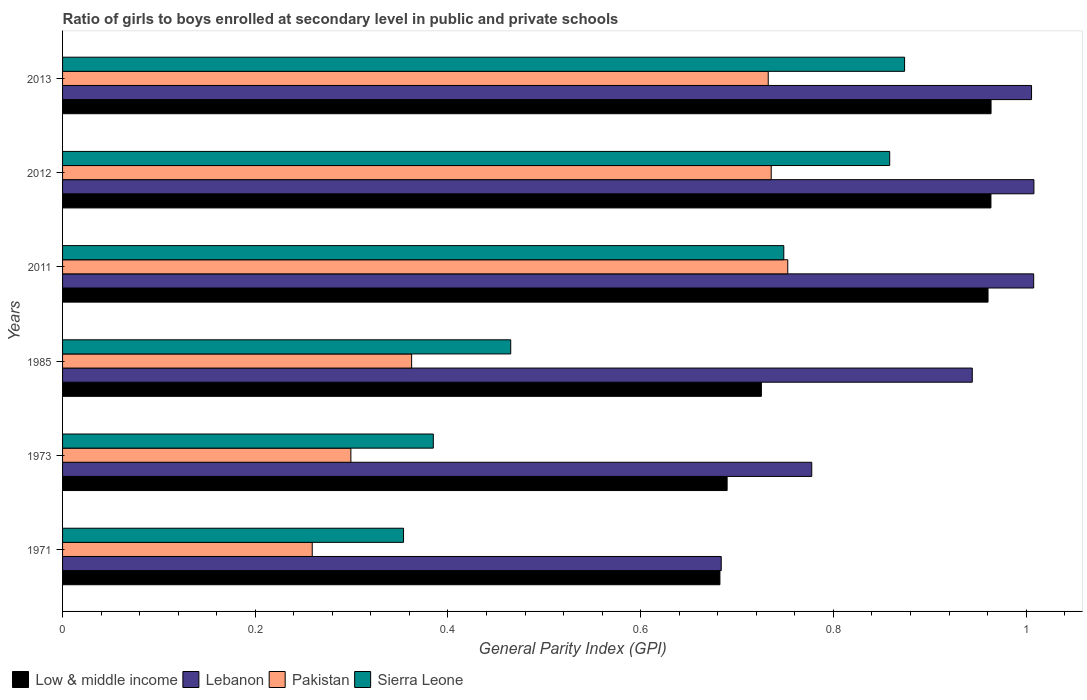How many different coloured bars are there?
Your answer should be very brief. 4. Are the number of bars on each tick of the Y-axis equal?
Offer a terse response. Yes. How many bars are there on the 6th tick from the top?
Your answer should be compact. 4. In how many cases, is the number of bars for a given year not equal to the number of legend labels?
Your answer should be compact. 0. What is the general parity index in Low & middle income in 1985?
Keep it short and to the point. 0.73. Across all years, what is the maximum general parity index in Sierra Leone?
Your response must be concise. 0.87. Across all years, what is the minimum general parity index in Pakistan?
Your response must be concise. 0.26. In which year was the general parity index in Lebanon minimum?
Make the answer very short. 1971. What is the total general parity index in Sierra Leone in the graph?
Offer a very short reply. 3.68. What is the difference between the general parity index in Low & middle income in 1971 and that in 2012?
Provide a succinct answer. -0.28. What is the difference between the general parity index in Pakistan in 2011 and the general parity index in Sierra Leone in 2013?
Your answer should be very brief. -0.12. What is the average general parity index in Sierra Leone per year?
Your response must be concise. 0.61. In the year 2011, what is the difference between the general parity index in Low & middle income and general parity index in Sierra Leone?
Give a very brief answer. 0.21. In how many years, is the general parity index in Low & middle income greater than 0.7200000000000001 ?
Your response must be concise. 4. What is the ratio of the general parity index in Low & middle income in 2011 to that in 2012?
Your response must be concise. 1. Is the general parity index in Pakistan in 1971 less than that in 2012?
Make the answer very short. Yes. What is the difference between the highest and the second highest general parity index in Lebanon?
Ensure brevity in your answer.  0. What is the difference between the highest and the lowest general parity index in Low & middle income?
Your answer should be very brief. 0.28. In how many years, is the general parity index in Low & middle income greater than the average general parity index in Low & middle income taken over all years?
Offer a terse response. 3. Is the sum of the general parity index in Pakistan in 1973 and 2012 greater than the maximum general parity index in Low & middle income across all years?
Keep it short and to the point. Yes. What does the 4th bar from the top in 1971 represents?
Give a very brief answer. Low & middle income. Is it the case that in every year, the sum of the general parity index in Pakistan and general parity index in Sierra Leone is greater than the general parity index in Lebanon?
Make the answer very short. No. How many bars are there?
Ensure brevity in your answer.  24. How many years are there in the graph?
Make the answer very short. 6. What is the difference between two consecutive major ticks on the X-axis?
Offer a very short reply. 0.2. Are the values on the major ticks of X-axis written in scientific E-notation?
Your response must be concise. No. What is the title of the graph?
Your answer should be compact. Ratio of girls to boys enrolled at secondary level in public and private schools. What is the label or title of the X-axis?
Give a very brief answer. General Parity Index (GPI). What is the General Parity Index (GPI) in Low & middle income in 1971?
Give a very brief answer. 0.68. What is the General Parity Index (GPI) of Lebanon in 1971?
Give a very brief answer. 0.68. What is the General Parity Index (GPI) of Pakistan in 1971?
Your answer should be compact. 0.26. What is the General Parity Index (GPI) in Sierra Leone in 1971?
Ensure brevity in your answer.  0.35. What is the General Parity Index (GPI) in Low & middle income in 1973?
Provide a short and direct response. 0.69. What is the General Parity Index (GPI) of Lebanon in 1973?
Make the answer very short. 0.78. What is the General Parity Index (GPI) of Pakistan in 1973?
Ensure brevity in your answer.  0.3. What is the General Parity Index (GPI) in Sierra Leone in 1973?
Provide a succinct answer. 0.38. What is the General Parity Index (GPI) of Low & middle income in 1985?
Offer a very short reply. 0.73. What is the General Parity Index (GPI) of Lebanon in 1985?
Provide a short and direct response. 0.94. What is the General Parity Index (GPI) of Pakistan in 1985?
Ensure brevity in your answer.  0.36. What is the General Parity Index (GPI) of Sierra Leone in 1985?
Offer a terse response. 0.47. What is the General Parity Index (GPI) in Low & middle income in 2011?
Keep it short and to the point. 0.96. What is the General Parity Index (GPI) of Lebanon in 2011?
Your response must be concise. 1.01. What is the General Parity Index (GPI) in Pakistan in 2011?
Provide a succinct answer. 0.75. What is the General Parity Index (GPI) of Sierra Leone in 2011?
Make the answer very short. 0.75. What is the General Parity Index (GPI) of Low & middle income in 2012?
Provide a short and direct response. 0.96. What is the General Parity Index (GPI) in Lebanon in 2012?
Give a very brief answer. 1.01. What is the General Parity Index (GPI) in Pakistan in 2012?
Your answer should be compact. 0.74. What is the General Parity Index (GPI) of Sierra Leone in 2012?
Your answer should be very brief. 0.86. What is the General Parity Index (GPI) of Low & middle income in 2013?
Offer a very short reply. 0.96. What is the General Parity Index (GPI) in Lebanon in 2013?
Offer a terse response. 1.01. What is the General Parity Index (GPI) of Pakistan in 2013?
Provide a short and direct response. 0.73. What is the General Parity Index (GPI) of Sierra Leone in 2013?
Your answer should be compact. 0.87. Across all years, what is the maximum General Parity Index (GPI) in Low & middle income?
Keep it short and to the point. 0.96. Across all years, what is the maximum General Parity Index (GPI) of Lebanon?
Keep it short and to the point. 1.01. Across all years, what is the maximum General Parity Index (GPI) in Pakistan?
Your response must be concise. 0.75. Across all years, what is the maximum General Parity Index (GPI) of Sierra Leone?
Ensure brevity in your answer.  0.87. Across all years, what is the minimum General Parity Index (GPI) in Low & middle income?
Ensure brevity in your answer.  0.68. Across all years, what is the minimum General Parity Index (GPI) in Lebanon?
Your answer should be compact. 0.68. Across all years, what is the minimum General Parity Index (GPI) of Pakistan?
Provide a short and direct response. 0.26. Across all years, what is the minimum General Parity Index (GPI) in Sierra Leone?
Provide a short and direct response. 0.35. What is the total General Parity Index (GPI) of Low & middle income in the graph?
Give a very brief answer. 4.98. What is the total General Parity Index (GPI) of Lebanon in the graph?
Provide a short and direct response. 5.43. What is the total General Parity Index (GPI) in Pakistan in the graph?
Your answer should be compact. 3.14. What is the total General Parity Index (GPI) in Sierra Leone in the graph?
Provide a succinct answer. 3.68. What is the difference between the General Parity Index (GPI) of Low & middle income in 1971 and that in 1973?
Offer a very short reply. -0.01. What is the difference between the General Parity Index (GPI) in Lebanon in 1971 and that in 1973?
Offer a very short reply. -0.09. What is the difference between the General Parity Index (GPI) of Pakistan in 1971 and that in 1973?
Give a very brief answer. -0.04. What is the difference between the General Parity Index (GPI) of Sierra Leone in 1971 and that in 1973?
Keep it short and to the point. -0.03. What is the difference between the General Parity Index (GPI) of Low & middle income in 1971 and that in 1985?
Keep it short and to the point. -0.04. What is the difference between the General Parity Index (GPI) of Lebanon in 1971 and that in 1985?
Give a very brief answer. -0.26. What is the difference between the General Parity Index (GPI) in Pakistan in 1971 and that in 1985?
Give a very brief answer. -0.1. What is the difference between the General Parity Index (GPI) of Sierra Leone in 1971 and that in 1985?
Ensure brevity in your answer.  -0.11. What is the difference between the General Parity Index (GPI) of Low & middle income in 1971 and that in 2011?
Your answer should be compact. -0.28. What is the difference between the General Parity Index (GPI) of Lebanon in 1971 and that in 2011?
Offer a terse response. -0.32. What is the difference between the General Parity Index (GPI) of Pakistan in 1971 and that in 2011?
Give a very brief answer. -0.49. What is the difference between the General Parity Index (GPI) of Sierra Leone in 1971 and that in 2011?
Your answer should be very brief. -0.39. What is the difference between the General Parity Index (GPI) of Low & middle income in 1971 and that in 2012?
Your response must be concise. -0.28. What is the difference between the General Parity Index (GPI) in Lebanon in 1971 and that in 2012?
Provide a short and direct response. -0.32. What is the difference between the General Parity Index (GPI) in Pakistan in 1971 and that in 2012?
Your answer should be compact. -0.48. What is the difference between the General Parity Index (GPI) in Sierra Leone in 1971 and that in 2012?
Ensure brevity in your answer.  -0.5. What is the difference between the General Parity Index (GPI) in Low & middle income in 1971 and that in 2013?
Give a very brief answer. -0.28. What is the difference between the General Parity Index (GPI) of Lebanon in 1971 and that in 2013?
Keep it short and to the point. -0.32. What is the difference between the General Parity Index (GPI) of Pakistan in 1971 and that in 2013?
Offer a very short reply. -0.47. What is the difference between the General Parity Index (GPI) in Sierra Leone in 1971 and that in 2013?
Your response must be concise. -0.52. What is the difference between the General Parity Index (GPI) of Low & middle income in 1973 and that in 1985?
Your answer should be very brief. -0.04. What is the difference between the General Parity Index (GPI) of Lebanon in 1973 and that in 1985?
Your response must be concise. -0.17. What is the difference between the General Parity Index (GPI) in Pakistan in 1973 and that in 1985?
Your answer should be very brief. -0.06. What is the difference between the General Parity Index (GPI) in Sierra Leone in 1973 and that in 1985?
Your answer should be compact. -0.08. What is the difference between the General Parity Index (GPI) in Low & middle income in 1973 and that in 2011?
Provide a short and direct response. -0.27. What is the difference between the General Parity Index (GPI) in Lebanon in 1973 and that in 2011?
Make the answer very short. -0.23. What is the difference between the General Parity Index (GPI) of Pakistan in 1973 and that in 2011?
Your answer should be very brief. -0.45. What is the difference between the General Parity Index (GPI) of Sierra Leone in 1973 and that in 2011?
Provide a short and direct response. -0.36. What is the difference between the General Parity Index (GPI) in Low & middle income in 1973 and that in 2012?
Ensure brevity in your answer.  -0.27. What is the difference between the General Parity Index (GPI) of Lebanon in 1973 and that in 2012?
Keep it short and to the point. -0.23. What is the difference between the General Parity Index (GPI) of Pakistan in 1973 and that in 2012?
Ensure brevity in your answer.  -0.44. What is the difference between the General Parity Index (GPI) of Sierra Leone in 1973 and that in 2012?
Offer a very short reply. -0.47. What is the difference between the General Parity Index (GPI) in Low & middle income in 1973 and that in 2013?
Provide a succinct answer. -0.27. What is the difference between the General Parity Index (GPI) in Lebanon in 1973 and that in 2013?
Offer a terse response. -0.23. What is the difference between the General Parity Index (GPI) in Pakistan in 1973 and that in 2013?
Provide a succinct answer. -0.43. What is the difference between the General Parity Index (GPI) in Sierra Leone in 1973 and that in 2013?
Offer a very short reply. -0.49. What is the difference between the General Parity Index (GPI) in Low & middle income in 1985 and that in 2011?
Offer a terse response. -0.24. What is the difference between the General Parity Index (GPI) in Lebanon in 1985 and that in 2011?
Your answer should be compact. -0.06. What is the difference between the General Parity Index (GPI) of Pakistan in 1985 and that in 2011?
Offer a very short reply. -0.39. What is the difference between the General Parity Index (GPI) in Sierra Leone in 1985 and that in 2011?
Offer a terse response. -0.28. What is the difference between the General Parity Index (GPI) in Low & middle income in 1985 and that in 2012?
Offer a very short reply. -0.24. What is the difference between the General Parity Index (GPI) in Lebanon in 1985 and that in 2012?
Keep it short and to the point. -0.06. What is the difference between the General Parity Index (GPI) of Pakistan in 1985 and that in 2012?
Offer a terse response. -0.37. What is the difference between the General Parity Index (GPI) of Sierra Leone in 1985 and that in 2012?
Offer a very short reply. -0.39. What is the difference between the General Parity Index (GPI) in Low & middle income in 1985 and that in 2013?
Ensure brevity in your answer.  -0.24. What is the difference between the General Parity Index (GPI) in Lebanon in 1985 and that in 2013?
Ensure brevity in your answer.  -0.06. What is the difference between the General Parity Index (GPI) of Pakistan in 1985 and that in 2013?
Provide a succinct answer. -0.37. What is the difference between the General Parity Index (GPI) in Sierra Leone in 1985 and that in 2013?
Offer a very short reply. -0.41. What is the difference between the General Parity Index (GPI) of Low & middle income in 2011 and that in 2012?
Provide a succinct answer. -0. What is the difference between the General Parity Index (GPI) in Lebanon in 2011 and that in 2012?
Provide a succinct answer. -0. What is the difference between the General Parity Index (GPI) of Pakistan in 2011 and that in 2012?
Keep it short and to the point. 0.02. What is the difference between the General Parity Index (GPI) of Sierra Leone in 2011 and that in 2012?
Offer a terse response. -0.11. What is the difference between the General Parity Index (GPI) of Low & middle income in 2011 and that in 2013?
Provide a succinct answer. -0. What is the difference between the General Parity Index (GPI) of Lebanon in 2011 and that in 2013?
Keep it short and to the point. 0. What is the difference between the General Parity Index (GPI) in Pakistan in 2011 and that in 2013?
Offer a very short reply. 0.02. What is the difference between the General Parity Index (GPI) of Sierra Leone in 2011 and that in 2013?
Your answer should be very brief. -0.13. What is the difference between the General Parity Index (GPI) in Low & middle income in 2012 and that in 2013?
Your response must be concise. -0. What is the difference between the General Parity Index (GPI) of Lebanon in 2012 and that in 2013?
Your response must be concise. 0. What is the difference between the General Parity Index (GPI) in Pakistan in 2012 and that in 2013?
Your answer should be very brief. 0. What is the difference between the General Parity Index (GPI) in Sierra Leone in 2012 and that in 2013?
Your answer should be compact. -0.02. What is the difference between the General Parity Index (GPI) of Low & middle income in 1971 and the General Parity Index (GPI) of Lebanon in 1973?
Keep it short and to the point. -0.1. What is the difference between the General Parity Index (GPI) of Low & middle income in 1971 and the General Parity Index (GPI) of Pakistan in 1973?
Provide a short and direct response. 0.38. What is the difference between the General Parity Index (GPI) in Low & middle income in 1971 and the General Parity Index (GPI) in Sierra Leone in 1973?
Provide a succinct answer. 0.3. What is the difference between the General Parity Index (GPI) of Lebanon in 1971 and the General Parity Index (GPI) of Pakistan in 1973?
Offer a very short reply. 0.38. What is the difference between the General Parity Index (GPI) of Lebanon in 1971 and the General Parity Index (GPI) of Sierra Leone in 1973?
Ensure brevity in your answer.  0.3. What is the difference between the General Parity Index (GPI) of Pakistan in 1971 and the General Parity Index (GPI) of Sierra Leone in 1973?
Give a very brief answer. -0.13. What is the difference between the General Parity Index (GPI) of Low & middle income in 1971 and the General Parity Index (GPI) of Lebanon in 1985?
Your answer should be very brief. -0.26. What is the difference between the General Parity Index (GPI) of Low & middle income in 1971 and the General Parity Index (GPI) of Pakistan in 1985?
Offer a very short reply. 0.32. What is the difference between the General Parity Index (GPI) of Low & middle income in 1971 and the General Parity Index (GPI) of Sierra Leone in 1985?
Keep it short and to the point. 0.22. What is the difference between the General Parity Index (GPI) in Lebanon in 1971 and the General Parity Index (GPI) in Pakistan in 1985?
Provide a succinct answer. 0.32. What is the difference between the General Parity Index (GPI) in Lebanon in 1971 and the General Parity Index (GPI) in Sierra Leone in 1985?
Offer a terse response. 0.22. What is the difference between the General Parity Index (GPI) in Pakistan in 1971 and the General Parity Index (GPI) in Sierra Leone in 1985?
Offer a very short reply. -0.21. What is the difference between the General Parity Index (GPI) of Low & middle income in 1971 and the General Parity Index (GPI) of Lebanon in 2011?
Offer a very short reply. -0.33. What is the difference between the General Parity Index (GPI) of Low & middle income in 1971 and the General Parity Index (GPI) of Pakistan in 2011?
Offer a very short reply. -0.07. What is the difference between the General Parity Index (GPI) in Low & middle income in 1971 and the General Parity Index (GPI) in Sierra Leone in 2011?
Provide a succinct answer. -0.07. What is the difference between the General Parity Index (GPI) in Lebanon in 1971 and the General Parity Index (GPI) in Pakistan in 2011?
Your answer should be compact. -0.07. What is the difference between the General Parity Index (GPI) of Lebanon in 1971 and the General Parity Index (GPI) of Sierra Leone in 2011?
Your answer should be compact. -0.06. What is the difference between the General Parity Index (GPI) in Pakistan in 1971 and the General Parity Index (GPI) in Sierra Leone in 2011?
Make the answer very short. -0.49. What is the difference between the General Parity Index (GPI) of Low & middle income in 1971 and the General Parity Index (GPI) of Lebanon in 2012?
Give a very brief answer. -0.33. What is the difference between the General Parity Index (GPI) of Low & middle income in 1971 and the General Parity Index (GPI) of Pakistan in 2012?
Your response must be concise. -0.05. What is the difference between the General Parity Index (GPI) in Low & middle income in 1971 and the General Parity Index (GPI) in Sierra Leone in 2012?
Offer a terse response. -0.18. What is the difference between the General Parity Index (GPI) in Lebanon in 1971 and the General Parity Index (GPI) in Pakistan in 2012?
Provide a short and direct response. -0.05. What is the difference between the General Parity Index (GPI) of Lebanon in 1971 and the General Parity Index (GPI) of Sierra Leone in 2012?
Provide a succinct answer. -0.17. What is the difference between the General Parity Index (GPI) of Pakistan in 1971 and the General Parity Index (GPI) of Sierra Leone in 2012?
Keep it short and to the point. -0.6. What is the difference between the General Parity Index (GPI) in Low & middle income in 1971 and the General Parity Index (GPI) in Lebanon in 2013?
Offer a very short reply. -0.32. What is the difference between the General Parity Index (GPI) in Low & middle income in 1971 and the General Parity Index (GPI) in Pakistan in 2013?
Ensure brevity in your answer.  -0.05. What is the difference between the General Parity Index (GPI) in Low & middle income in 1971 and the General Parity Index (GPI) in Sierra Leone in 2013?
Provide a short and direct response. -0.19. What is the difference between the General Parity Index (GPI) of Lebanon in 1971 and the General Parity Index (GPI) of Pakistan in 2013?
Provide a succinct answer. -0.05. What is the difference between the General Parity Index (GPI) in Lebanon in 1971 and the General Parity Index (GPI) in Sierra Leone in 2013?
Your response must be concise. -0.19. What is the difference between the General Parity Index (GPI) of Pakistan in 1971 and the General Parity Index (GPI) of Sierra Leone in 2013?
Your answer should be compact. -0.61. What is the difference between the General Parity Index (GPI) of Low & middle income in 1973 and the General Parity Index (GPI) of Lebanon in 1985?
Ensure brevity in your answer.  -0.25. What is the difference between the General Parity Index (GPI) in Low & middle income in 1973 and the General Parity Index (GPI) in Pakistan in 1985?
Provide a succinct answer. 0.33. What is the difference between the General Parity Index (GPI) in Low & middle income in 1973 and the General Parity Index (GPI) in Sierra Leone in 1985?
Keep it short and to the point. 0.22. What is the difference between the General Parity Index (GPI) of Lebanon in 1973 and the General Parity Index (GPI) of Pakistan in 1985?
Ensure brevity in your answer.  0.42. What is the difference between the General Parity Index (GPI) of Lebanon in 1973 and the General Parity Index (GPI) of Sierra Leone in 1985?
Your answer should be compact. 0.31. What is the difference between the General Parity Index (GPI) of Pakistan in 1973 and the General Parity Index (GPI) of Sierra Leone in 1985?
Your answer should be very brief. -0.17. What is the difference between the General Parity Index (GPI) of Low & middle income in 1973 and the General Parity Index (GPI) of Lebanon in 2011?
Offer a very short reply. -0.32. What is the difference between the General Parity Index (GPI) of Low & middle income in 1973 and the General Parity Index (GPI) of Pakistan in 2011?
Make the answer very short. -0.06. What is the difference between the General Parity Index (GPI) in Low & middle income in 1973 and the General Parity Index (GPI) in Sierra Leone in 2011?
Your response must be concise. -0.06. What is the difference between the General Parity Index (GPI) of Lebanon in 1973 and the General Parity Index (GPI) of Pakistan in 2011?
Keep it short and to the point. 0.02. What is the difference between the General Parity Index (GPI) of Lebanon in 1973 and the General Parity Index (GPI) of Sierra Leone in 2011?
Give a very brief answer. 0.03. What is the difference between the General Parity Index (GPI) in Pakistan in 1973 and the General Parity Index (GPI) in Sierra Leone in 2011?
Keep it short and to the point. -0.45. What is the difference between the General Parity Index (GPI) of Low & middle income in 1973 and the General Parity Index (GPI) of Lebanon in 2012?
Your response must be concise. -0.32. What is the difference between the General Parity Index (GPI) in Low & middle income in 1973 and the General Parity Index (GPI) in Pakistan in 2012?
Offer a very short reply. -0.05. What is the difference between the General Parity Index (GPI) of Low & middle income in 1973 and the General Parity Index (GPI) of Sierra Leone in 2012?
Ensure brevity in your answer.  -0.17. What is the difference between the General Parity Index (GPI) of Lebanon in 1973 and the General Parity Index (GPI) of Pakistan in 2012?
Provide a succinct answer. 0.04. What is the difference between the General Parity Index (GPI) in Lebanon in 1973 and the General Parity Index (GPI) in Sierra Leone in 2012?
Keep it short and to the point. -0.08. What is the difference between the General Parity Index (GPI) of Pakistan in 1973 and the General Parity Index (GPI) of Sierra Leone in 2012?
Your answer should be very brief. -0.56. What is the difference between the General Parity Index (GPI) in Low & middle income in 1973 and the General Parity Index (GPI) in Lebanon in 2013?
Make the answer very short. -0.32. What is the difference between the General Parity Index (GPI) of Low & middle income in 1973 and the General Parity Index (GPI) of Pakistan in 2013?
Make the answer very short. -0.04. What is the difference between the General Parity Index (GPI) of Low & middle income in 1973 and the General Parity Index (GPI) of Sierra Leone in 2013?
Offer a very short reply. -0.18. What is the difference between the General Parity Index (GPI) in Lebanon in 1973 and the General Parity Index (GPI) in Pakistan in 2013?
Give a very brief answer. 0.05. What is the difference between the General Parity Index (GPI) of Lebanon in 1973 and the General Parity Index (GPI) of Sierra Leone in 2013?
Offer a very short reply. -0.1. What is the difference between the General Parity Index (GPI) of Pakistan in 1973 and the General Parity Index (GPI) of Sierra Leone in 2013?
Keep it short and to the point. -0.57. What is the difference between the General Parity Index (GPI) in Low & middle income in 1985 and the General Parity Index (GPI) in Lebanon in 2011?
Give a very brief answer. -0.28. What is the difference between the General Parity Index (GPI) in Low & middle income in 1985 and the General Parity Index (GPI) in Pakistan in 2011?
Keep it short and to the point. -0.03. What is the difference between the General Parity Index (GPI) of Low & middle income in 1985 and the General Parity Index (GPI) of Sierra Leone in 2011?
Keep it short and to the point. -0.02. What is the difference between the General Parity Index (GPI) of Lebanon in 1985 and the General Parity Index (GPI) of Pakistan in 2011?
Keep it short and to the point. 0.19. What is the difference between the General Parity Index (GPI) of Lebanon in 1985 and the General Parity Index (GPI) of Sierra Leone in 2011?
Your response must be concise. 0.2. What is the difference between the General Parity Index (GPI) in Pakistan in 1985 and the General Parity Index (GPI) in Sierra Leone in 2011?
Your answer should be compact. -0.39. What is the difference between the General Parity Index (GPI) of Low & middle income in 1985 and the General Parity Index (GPI) of Lebanon in 2012?
Offer a very short reply. -0.28. What is the difference between the General Parity Index (GPI) in Low & middle income in 1985 and the General Parity Index (GPI) in Pakistan in 2012?
Keep it short and to the point. -0.01. What is the difference between the General Parity Index (GPI) in Low & middle income in 1985 and the General Parity Index (GPI) in Sierra Leone in 2012?
Offer a terse response. -0.13. What is the difference between the General Parity Index (GPI) of Lebanon in 1985 and the General Parity Index (GPI) of Pakistan in 2012?
Offer a terse response. 0.21. What is the difference between the General Parity Index (GPI) of Lebanon in 1985 and the General Parity Index (GPI) of Sierra Leone in 2012?
Make the answer very short. 0.09. What is the difference between the General Parity Index (GPI) of Pakistan in 1985 and the General Parity Index (GPI) of Sierra Leone in 2012?
Your answer should be compact. -0.5. What is the difference between the General Parity Index (GPI) of Low & middle income in 1985 and the General Parity Index (GPI) of Lebanon in 2013?
Your answer should be very brief. -0.28. What is the difference between the General Parity Index (GPI) in Low & middle income in 1985 and the General Parity Index (GPI) in Pakistan in 2013?
Make the answer very short. -0.01. What is the difference between the General Parity Index (GPI) of Low & middle income in 1985 and the General Parity Index (GPI) of Sierra Leone in 2013?
Your answer should be very brief. -0.15. What is the difference between the General Parity Index (GPI) of Lebanon in 1985 and the General Parity Index (GPI) of Pakistan in 2013?
Your answer should be compact. 0.21. What is the difference between the General Parity Index (GPI) in Lebanon in 1985 and the General Parity Index (GPI) in Sierra Leone in 2013?
Your answer should be compact. 0.07. What is the difference between the General Parity Index (GPI) in Pakistan in 1985 and the General Parity Index (GPI) in Sierra Leone in 2013?
Offer a very short reply. -0.51. What is the difference between the General Parity Index (GPI) in Low & middle income in 2011 and the General Parity Index (GPI) in Lebanon in 2012?
Give a very brief answer. -0.05. What is the difference between the General Parity Index (GPI) of Low & middle income in 2011 and the General Parity Index (GPI) of Pakistan in 2012?
Your answer should be very brief. 0.23. What is the difference between the General Parity Index (GPI) in Low & middle income in 2011 and the General Parity Index (GPI) in Sierra Leone in 2012?
Offer a very short reply. 0.1. What is the difference between the General Parity Index (GPI) in Lebanon in 2011 and the General Parity Index (GPI) in Pakistan in 2012?
Give a very brief answer. 0.27. What is the difference between the General Parity Index (GPI) of Lebanon in 2011 and the General Parity Index (GPI) of Sierra Leone in 2012?
Offer a very short reply. 0.15. What is the difference between the General Parity Index (GPI) in Pakistan in 2011 and the General Parity Index (GPI) in Sierra Leone in 2012?
Your answer should be compact. -0.11. What is the difference between the General Parity Index (GPI) in Low & middle income in 2011 and the General Parity Index (GPI) in Lebanon in 2013?
Provide a succinct answer. -0.05. What is the difference between the General Parity Index (GPI) of Low & middle income in 2011 and the General Parity Index (GPI) of Pakistan in 2013?
Your response must be concise. 0.23. What is the difference between the General Parity Index (GPI) in Low & middle income in 2011 and the General Parity Index (GPI) in Sierra Leone in 2013?
Offer a terse response. 0.09. What is the difference between the General Parity Index (GPI) in Lebanon in 2011 and the General Parity Index (GPI) in Pakistan in 2013?
Your answer should be very brief. 0.28. What is the difference between the General Parity Index (GPI) in Lebanon in 2011 and the General Parity Index (GPI) in Sierra Leone in 2013?
Your response must be concise. 0.13. What is the difference between the General Parity Index (GPI) of Pakistan in 2011 and the General Parity Index (GPI) of Sierra Leone in 2013?
Provide a short and direct response. -0.12. What is the difference between the General Parity Index (GPI) of Low & middle income in 2012 and the General Parity Index (GPI) of Lebanon in 2013?
Offer a very short reply. -0.04. What is the difference between the General Parity Index (GPI) in Low & middle income in 2012 and the General Parity Index (GPI) in Pakistan in 2013?
Provide a succinct answer. 0.23. What is the difference between the General Parity Index (GPI) of Low & middle income in 2012 and the General Parity Index (GPI) of Sierra Leone in 2013?
Your answer should be very brief. 0.09. What is the difference between the General Parity Index (GPI) in Lebanon in 2012 and the General Parity Index (GPI) in Pakistan in 2013?
Your response must be concise. 0.28. What is the difference between the General Parity Index (GPI) in Lebanon in 2012 and the General Parity Index (GPI) in Sierra Leone in 2013?
Provide a short and direct response. 0.13. What is the difference between the General Parity Index (GPI) of Pakistan in 2012 and the General Parity Index (GPI) of Sierra Leone in 2013?
Your answer should be very brief. -0.14. What is the average General Parity Index (GPI) in Low & middle income per year?
Provide a succinct answer. 0.83. What is the average General Parity Index (GPI) in Lebanon per year?
Offer a terse response. 0.9. What is the average General Parity Index (GPI) of Pakistan per year?
Your answer should be very brief. 0.52. What is the average General Parity Index (GPI) of Sierra Leone per year?
Your answer should be compact. 0.61. In the year 1971, what is the difference between the General Parity Index (GPI) of Low & middle income and General Parity Index (GPI) of Lebanon?
Make the answer very short. -0. In the year 1971, what is the difference between the General Parity Index (GPI) in Low & middle income and General Parity Index (GPI) in Pakistan?
Provide a short and direct response. 0.42. In the year 1971, what is the difference between the General Parity Index (GPI) in Low & middle income and General Parity Index (GPI) in Sierra Leone?
Make the answer very short. 0.33. In the year 1971, what is the difference between the General Parity Index (GPI) in Lebanon and General Parity Index (GPI) in Pakistan?
Your answer should be very brief. 0.42. In the year 1971, what is the difference between the General Parity Index (GPI) of Lebanon and General Parity Index (GPI) of Sierra Leone?
Your response must be concise. 0.33. In the year 1971, what is the difference between the General Parity Index (GPI) of Pakistan and General Parity Index (GPI) of Sierra Leone?
Offer a terse response. -0.09. In the year 1973, what is the difference between the General Parity Index (GPI) in Low & middle income and General Parity Index (GPI) in Lebanon?
Provide a succinct answer. -0.09. In the year 1973, what is the difference between the General Parity Index (GPI) of Low & middle income and General Parity Index (GPI) of Pakistan?
Offer a terse response. 0.39. In the year 1973, what is the difference between the General Parity Index (GPI) in Low & middle income and General Parity Index (GPI) in Sierra Leone?
Give a very brief answer. 0.3. In the year 1973, what is the difference between the General Parity Index (GPI) in Lebanon and General Parity Index (GPI) in Pakistan?
Give a very brief answer. 0.48. In the year 1973, what is the difference between the General Parity Index (GPI) of Lebanon and General Parity Index (GPI) of Sierra Leone?
Ensure brevity in your answer.  0.39. In the year 1973, what is the difference between the General Parity Index (GPI) of Pakistan and General Parity Index (GPI) of Sierra Leone?
Provide a short and direct response. -0.09. In the year 1985, what is the difference between the General Parity Index (GPI) of Low & middle income and General Parity Index (GPI) of Lebanon?
Your response must be concise. -0.22. In the year 1985, what is the difference between the General Parity Index (GPI) in Low & middle income and General Parity Index (GPI) in Pakistan?
Give a very brief answer. 0.36. In the year 1985, what is the difference between the General Parity Index (GPI) in Low & middle income and General Parity Index (GPI) in Sierra Leone?
Your answer should be very brief. 0.26. In the year 1985, what is the difference between the General Parity Index (GPI) in Lebanon and General Parity Index (GPI) in Pakistan?
Give a very brief answer. 0.58. In the year 1985, what is the difference between the General Parity Index (GPI) of Lebanon and General Parity Index (GPI) of Sierra Leone?
Your answer should be very brief. 0.48. In the year 1985, what is the difference between the General Parity Index (GPI) in Pakistan and General Parity Index (GPI) in Sierra Leone?
Give a very brief answer. -0.1. In the year 2011, what is the difference between the General Parity Index (GPI) of Low & middle income and General Parity Index (GPI) of Lebanon?
Ensure brevity in your answer.  -0.05. In the year 2011, what is the difference between the General Parity Index (GPI) of Low & middle income and General Parity Index (GPI) of Pakistan?
Give a very brief answer. 0.21. In the year 2011, what is the difference between the General Parity Index (GPI) in Low & middle income and General Parity Index (GPI) in Sierra Leone?
Your answer should be very brief. 0.21. In the year 2011, what is the difference between the General Parity Index (GPI) of Lebanon and General Parity Index (GPI) of Pakistan?
Your answer should be very brief. 0.26. In the year 2011, what is the difference between the General Parity Index (GPI) in Lebanon and General Parity Index (GPI) in Sierra Leone?
Your response must be concise. 0.26. In the year 2011, what is the difference between the General Parity Index (GPI) of Pakistan and General Parity Index (GPI) of Sierra Leone?
Your answer should be compact. 0. In the year 2012, what is the difference between the General Parity Index (GPI) in Low & middle income and General Parity Index (GPI) in Lebanon?
Offer a very short reply. -0.04. In the year 2012, what is the difference between the General Parity Index (GPI) of Low & middle income and General Parity Index (GPI) of Pakistan?
Give a very brief answer. 0.23. In the year 2012, what is the difference between the General Parity Index (GPI) of Low & middle income and General Parity Index (GPI) of Sierra Leone?
Give a very brief answer. 0.11. In the year 2012, what is the difference between the General Parity Index (GPI) of Lebanon and General Parity Index (GPI) of Pakistan?
Your answer should be compact. 0.27. In the year 2012, what is the difference between the General Parity Index (GPI) in Lebanon and General Parity Index (GPI) in Sierra Leone?
Make the answer very short. 0.15. In the year 2012, what is the difference between the General Parity Index (GPI) in Pakistan and General Parity Index (GPI) in Sierra Leone?
Make the answer very short. -0.12. In the year 2013, what is the difference between the General Parity Index (GPI) in Low & middle income and General Parity Index (GPI) in Lebanon?
Keep it short and to the point. -0.04. In the year 2013, what is the difference between the General Parity Index (GPI) of Low & middle income and General Parity Index (GPI) of Pakistan?
Make the answer very short. 0.23. In the year 2013, what is the difference between the General Parity Index (GPI) in Low & middle income and General Parity Index (GPI) in Sierra Leone?
Provide a succinct answer. 0.09. In the year 2013, what is the difference between the General Parity Index (GPI) in Lebanon and General Parity Index (GPI) in Pakistan?
Make the answer very short. 0.27. In the year 2013, what is the difference between the General Parity Index (GPI) of Lebanon and General Parity Index (GPI) of Sierra Leone?
Ensure brevity in your answer.  0.13. In the year 2013, what is the difference between the General Parity Index (GPI) in Pakistan and General Parity Index (GPI) in Sierra Leone?
Make the answer very short. -0.14. What is the ratio of the General Parity Index (GPI) of Lebanon in 1971 to that in 1973?
Make the answer very short. 0.88. What is the ratio of the General Parity Index (GPI) of Pakistan in 1971 to that in 1973?
Offer a terse response. 0.87. What is the ratio of the General Parity Index (GPI) in Sierra Leone in 1971 to that in 1973?
Offer a terse response. 0.92. What is the ratio of the General Parity Index (GPI) of Low & middle income in 1971 to that in 1985?
Your answer should be compact. 0.94. What is the ratio of the General Parity Index (GPI) in Lebanon in 1971 to that in 1985?
Provide a succinct answer. 0.72. What is the ratio of the General Parity Index (GPI) in Pakistan in 1971 to that in 1985?
Your answer should be compact. 0.72. What is the ratio of the General Parity Index (GPI) of Sierra Leone in 1971 to that in 1985?
Your answer should be very brief. 0.76. What is the ratio of the General Parity Index (GPI) of Low & middle income in 1971 to that in 2011?
Your answer should be compact. 0.71. What is the ratio of the General Parity Index (GPI) of Lebanon in 1971 to that in 2011?
Provide a short and direct response. 0.68. What is the ratio of the General Parity Index (GPI) in Pakistan in 1971 to that in 2011?
Give a very brief answer. 0.34. What is the ratio of the General Parity Index (GPI) in Sierra Leone in 1971 to that in 2011?
Your answer should be very brief. 0.47. What is the ratio of the General Parity Index (GPI) in Low & middle income in 1971 to that in 2012?
Your answer should be compact. 0.71. What is the ratio of the General Parity Index (GPI) of Lebanon in 1971 to that in 2012?
Provide a short and direct response. 0.68. What is the ratio of the General Parity Index (GPI) in Pakistan in 1971 to that in 2012?
Give a very brief answer. 0.35. What is the ratio of the General Parity Index (GPI) of Sierra Leone in 1971 to that in 2012?
Make the answer very short. 0.41. What is the ratio of the General Parity Index (GPI) in Low & middle income in 1971 to that in 2013?
Offer a very short reply. 0.71. What is the ratio of the General Parity Index (GPI) of Lebanon in 1971 to that in 2013?
Offer a terse response. 0.68. What is the ratio of the General Parity Index (GPI) in Pakistan in 1971 to that in 2013?
Your answer should be very brief. 0.35. What is the ratio of the General Parity Index (GPI) of Sierra Leone in 1971 to that in 2013?
Offer a terse response. 0.41. What is the ratio of the General Parity Index (GPI) of Low & middle income in 1973 to that in 1985?
Your answer should be very brief. 0.95. What is the ratio of the General Parity Index (GPI) of Lebanon in 1973 to that in 1985?
Keep it short and to the point. 0.82. What is the ratio of the General Parity Index (GPI) of Pakistan in 1973 to that in 1985?
Your answer should be very brief. 0.83. What is the ratio of the General Parity Index (GPI) in Sierra Leone in 1973 to that in 1985?
Provide a succinct answer. 0.83. What is the ratio of the General Parity Index (GPI) of Low & middle income in 1973 to that in 2011?
Offer a terse response. 0.72. What is the ratio of the General Parity Index (GPI) of Lebanon in 1973 to that in 2011?
Your answer should be compact. 0.77. What is the ratio of the General Parity Index (GPI) in Pakistan in 1973 to that in 2011?
Your answer should be compact. 0.4. What is the ratio of the General Parity Index (GPI) in Sierra Leone in 1973 to that in 2011?
Provide a short and direct response. 0.51. What is the ratio of the General Parity Index (GPI) in Low & middle income in 1973 to that in 2012?
Your answer should be very brief. 0.72. What is the ratio of the General Parity Index (GPI) of Lebanon in 1973 to that in 2012?
Provide a short and direct response. 0.77. What is the ratio of the General Parity Index (GPI) of Pakistan in 1973 to that in 2012?
Your response must be concise. 0.41. What is the ratio of the General Parity Index (GPI) in Sierra Leone in 1973 to that in 2012?
Offer a terse response. 0.45. What is the ratio of the General Parity Index (GPI) of Low & middle income in 1973 to that in 2013?
Offer a terse response. 0.72. What is the ratio of the General Parity Index (GPI) in Lebanon in 1973 to that in 2013?
Make the answer very short. 0.77. What is the ratio of the General Parity Index (GPI) of Pakistan in 1973 to that in 2013?
Provide a succinct answer. 0.41. What is the ratio of the General Parity Index (GPI) of Sierra Leone in 1973 to that in 2013?
Make the answer very short. 0.44. What is the ratio of the General Parity Index (GPI) of Low & middle income in 1985 to that in 2011?
Provide a short and direct response. 0.76. What is the ratio of the General Parity Index (GPI) in Lebanon in 1985 to that in 2011?
Keep it short and to the point. 0.94. What is the ratio of the General Parity Index (GPI) in Pakistan in 1985 to that in 2011?
Make the answer very short. 0.48. What is the ratio of the General Parity Index (GPI) in Sierra Leone in 1985 to that in 2011?
Make the answer very short. 0.62. What is the ratio of the General Parity Index (GPI) of Low & middle income in 1985 to that in 2012?
Give a very brief answer. 0.75. What is the ratio of the General Parity Index (GPI) of Lebanon in 1985 to that in 2012?
Your response must be concise. 0.94. What is the ratio of the General Parity Index (GPI) of Pakistan in 1985 to that in 2012?
Your response must be concise. 0.49. What is the ratio of the General Parity Index (GPI) in Sierra Leone in 1985 to that in 2012?
Your response must be concise. 0.54. What is the ratio of the General Parity Index (GPI) of Low & middle income in 1985 to that in 2013?
Provide a short and direct response. 0.75. What is the ratio of the General Parity Index (GPI) in Lebanon in 1985 to that in 2013?
Provide a short and direct response. 0.94. What is the ratio of the General Parity Index (GPI) of Pakistan in 1985 to that in 2013?
Your response must be concise. 0.49. What is the ratio of the General Parity Index (GPI) in Sierra Leone in 1985 to that in 2013?
Provide a short and direct response. 0.53. What is the ratio of the General Parity Index (GPI) in Lebanon in 2011 to that in 2012?
Your answer should be compact. 1. What is the ratio of the General Parity Index (GPI) in Pakistan in 2011 to that in 2012?
Give a very brief answer. 1.02. What is the ratio of the General Parity Index (GPI) in Sierra Leone in 2011 to that in 2012?
Make the answer very short. 0.87. What is the ratio of the General Parity Index (GPI) in Pakistan in 2011 to that in 2013?
Make the answer very short. 1.03. What is the ratio of the General Parity Index (GPI) of Sierra Leone in 2011 to that in 2013?
Your answer should be very brief. 0.86. What is the ratio of the General Parity Index (GPI) of Low & middle income in 2012 to that in 2013?
Offer a very short reply. 1. What is the ratio of the General Parity Index (GPI) in Sierra Leone in 2012 to that in 2013?
Provide a short and direct response. 0.98. What is the difference between the highest and the second highest General Parity Index (GPI) of Low & middle income?
Offer a terse response. 0. What is the difference between the highest and the second highest General Parity Index (GPI) of Lebanon?
Your answer should be very brief. 0. What is the difference between the highest and the second highest General Parity Index (GPI) in Pakistan?
Provide a short and direct response. 0.02. What is the difference between the highest and the second highest General Parity Index (GPI) in Sierra Leone?
Your answer should be compact. 0.02. What is the difference between the highest and the lowest General Parity Index (GPI) of Low & middle income?
Give a very brief answer. 0.28. What is the difference between the highest and the lowest General Parity Index (GPI) in Lebanon?
Provide a succinct answer. 0.32. What is the difference between the highest and the lowest General Parity Index (GPI) of Pakistan?
Offer a very short reply. 0.49. What is the difference between the highest and the lowest General Parity Index (GPI) in Sierra Leone?
Give a very brief answer. 0.52. 